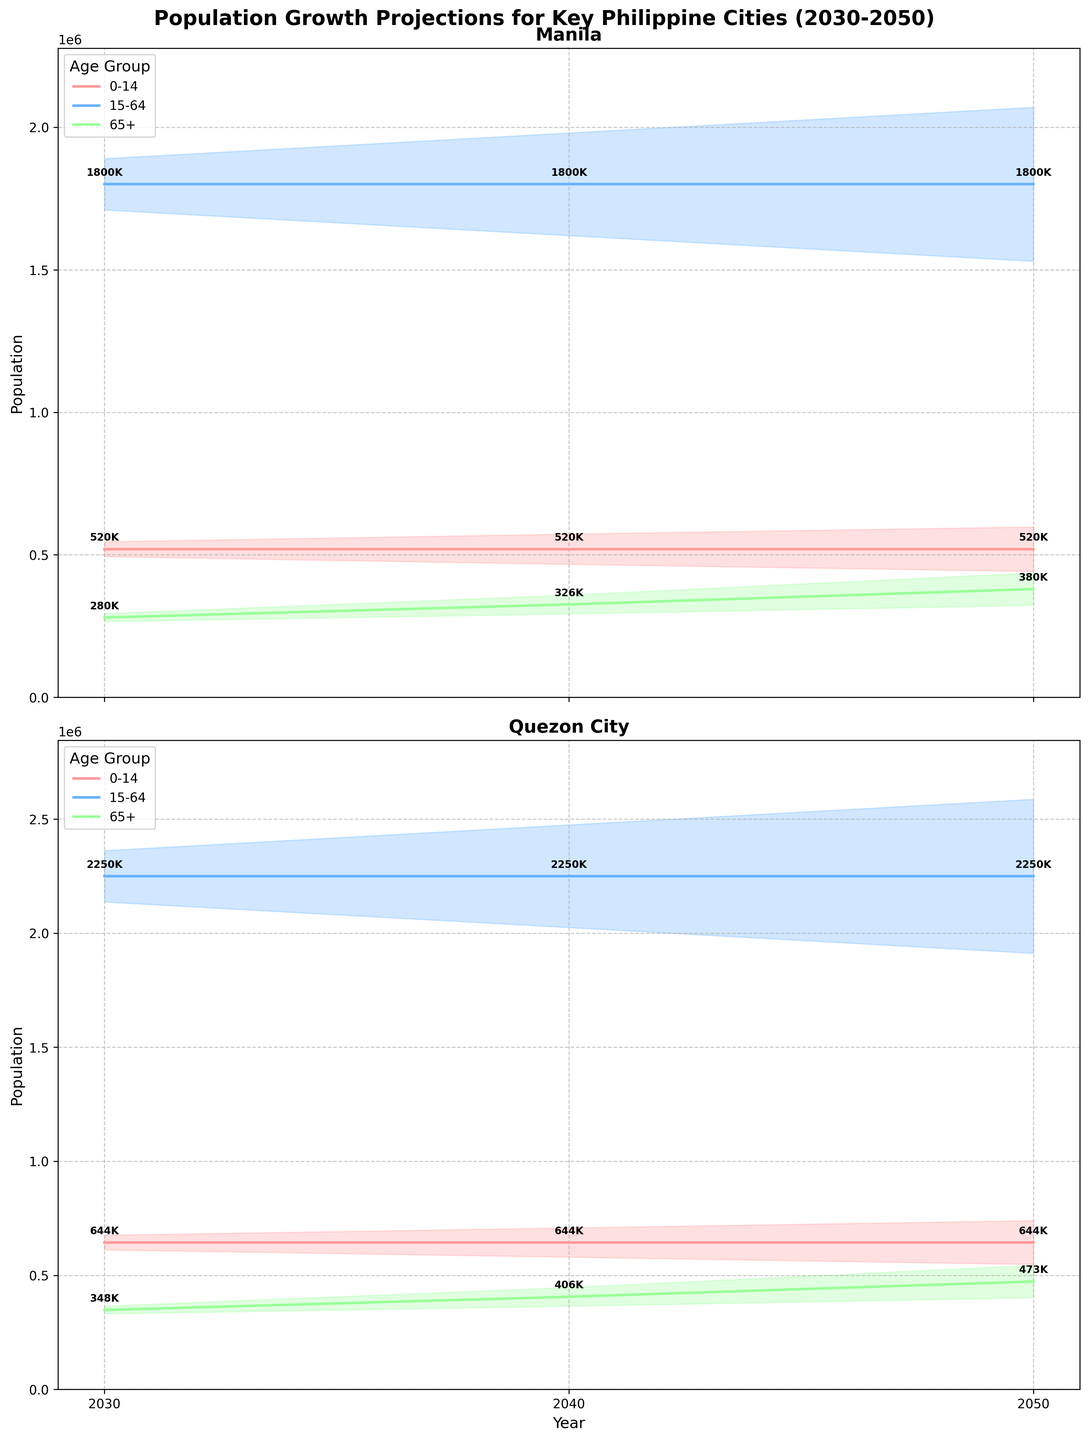what is the title of the figure? The title is clearly displayed at the top of the figure as "Population Growth Projections for Key Philippine Cities (2030-2050)".
Answer: Population Growth Projections for Key Philippine Cities (2030-2050) How many cities are presented in the figure? There are only two subplots presented in the figure, each corresponding to a different city.
Answer: Two Which age group in Quezon City is projected to have the smallest population in 2040? You need to compare the medium estimates of all age groups in Quezon City for 2040. The smallest population among them is for the age group 65+ with an estimate of 406,000.
Answer: 65+ What is the projected medium estimate for the 0-14 age group in Manila for the year 2050? Referring specifically to the plotted values for the 0-14 age group in Manila in 2050, the medium estimate can be found as 520,000.
Answer: 520,000 How does the projected medium estimate population of the 15-64 age group in Quezon City change from 2030 to 2050? Calculate the difference between 2250000 (2050) and 2250000 (2030). Since both years have the same medium estimate, the change is 0.
Answer: 0 What age group in Manila is projected to grow the most between 2030 and 2050 based on the medium estimates? To find this, calculate the growth for each age group by finding the difference between their 2050 and 2030 medium estimates: 0-14 (520000 - 520000 = 0), 15-64 (1800000 - 1800000 = 0), 65+ (380000 - 280000 = 100000). The 65+ age group has the largest growth.
Answer: 65+ Which city is expected to have a higher medium estimate population for the 0-14 age group by 2050, Manila or Quezon City? Compare the 2050 medium estimates for the 0-14 age group in both cities: Quezon City (644,000) is higher than Manila (520,000).
Answer: Quezon City What is the general trend for the 15-64 age group population between 2030 and 2050 in both cities? Overall, there is no significant change for 15-64 age group in either city; both cities have the same medium estimate of 1800000 in 2030 and 2050, showing relative stability.
Answer: Stable Which age group is consistently expected to have the highest population in both cities from 2030 to 2050? Look at the different years and observe which age group has the highest medium estimates consistently in both Manila and Quezon City; it is the 15-64 age group.
Answer: 15-64 Between 2030 and 2050, which city shows a wider range of population estimates for the 65+ age group? Observe the low and high estimates for the 65+ age group in both cities over the years. Quezon City shows a wider range of estimates compared to Manila.
Answer: Quezon City 